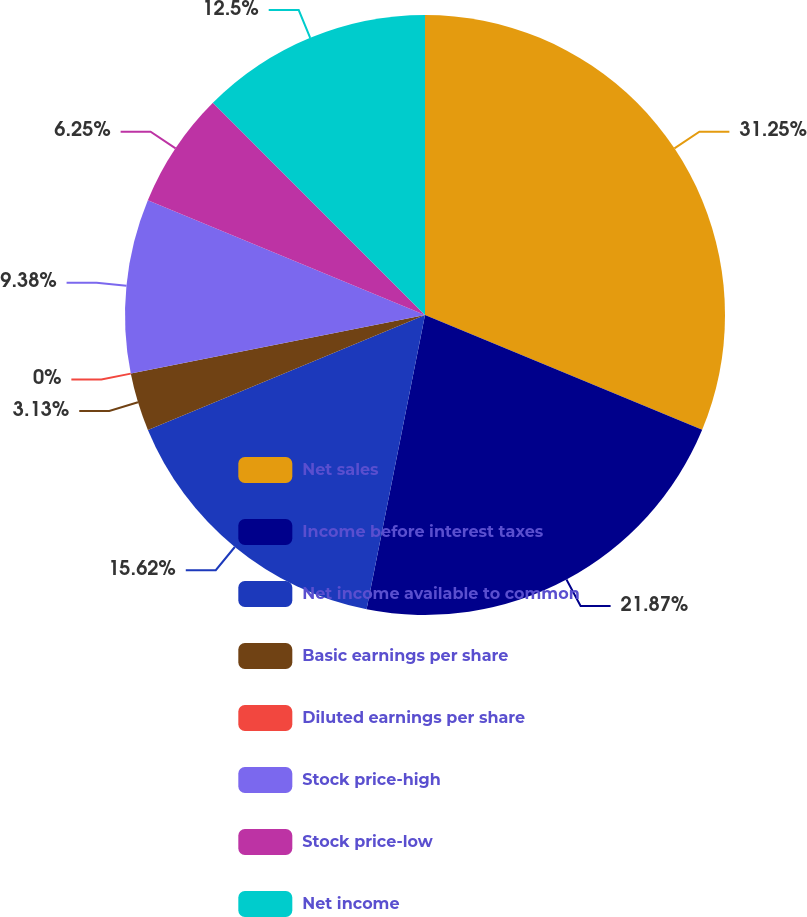Convert chart. <chart><loc_0><loc_0><loc_500><loc_500><pie_chart><fcel>Net sales<fcel>Income before interest taxes<fcel>Net income available to common<fcel>Basic earnings per share<fcel>Diluted earnings per share<fcel>Stock price-high<fcel>Stock price-low<fcel>Net income<nl><fcel>31.25%<fcel>21.87%<fcel>15.62%<fcel>3.13%<fcel>0.0%<fcel>9.38%<fcel>6.25%<fcel>12.5%<nl></chart> 